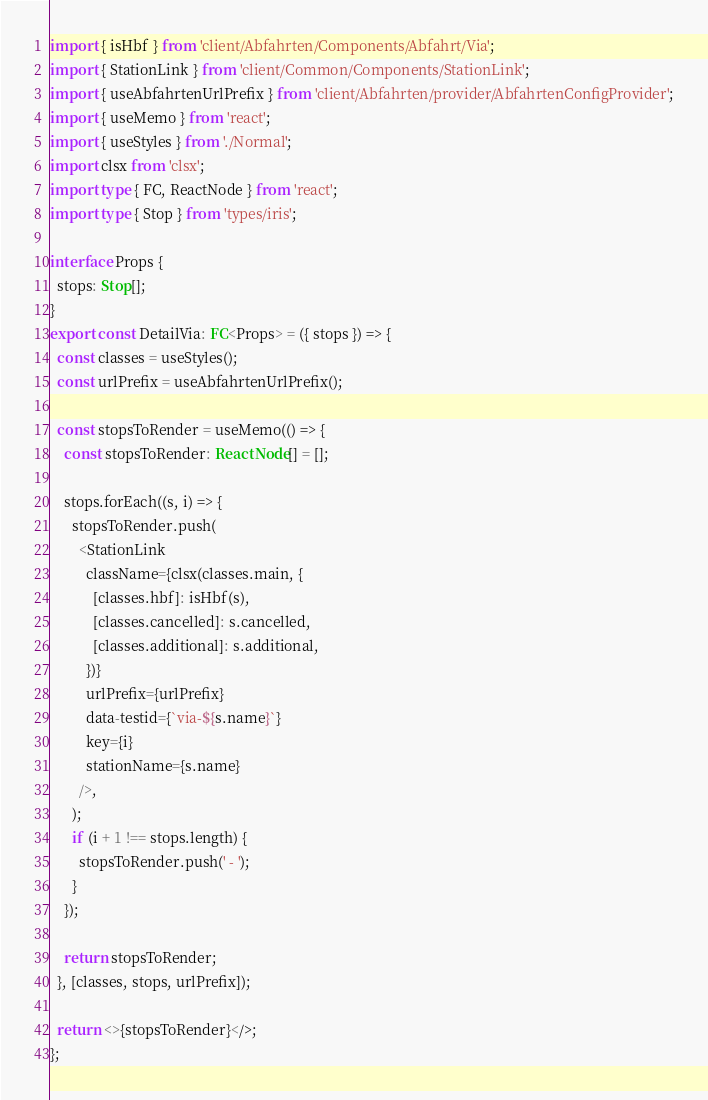<code> <loc_0><loc_0><loc_500><loc_500><_TypeScript_>import { isHbf } from 'client/Abfahrten/Components/Abfahrt/Via';
import { StationLink } from 'client/Common/Components/StationLink';
import { useAbfahrtenUrlPrefix } from 'client/Abfahrten/provider/AbfahrtenConfigProvider';
import { useMemo } from 'react';
import { useStyles } from './Normal';
import clsx from 'clsx';
import type { FC, ReactNode } from 'react';
import type { Stop } from 'types/iris';

interface Props {
  stops: Stop[];
}
export const DetailVia: FC<Props> = ({ stops }) => {
  const classes = useStyles();
  const urlPrefix = useAbfahrtenUrlPrefix();

  const stopsToRender = useMemo(() => {
    const stopsToRender: ReactNode[] = [];

    stops.forEach((s, i) => {
      stopsToRender.push(
        <StationLink
          className={clsx(classes.main, {
            [classes.hbf]: isHbf(s),
            [classes.cancelled]: s.cancelled,
            [classes.additional]: s.additional,
          })}
          urlPrefix={urlPrefix}
          data-testid={`via-${s.name}`}
          key={i}
          stationName={s.name}
        />,
      );
      if (i + 1 !== stops.length) {
        stopsToRender.push(' - ');
      }
    });

    return stopsToRender;
  }, [classes, stops, urlPrefix]);

  return <>{stopsToRender}</>;
};
</code> 